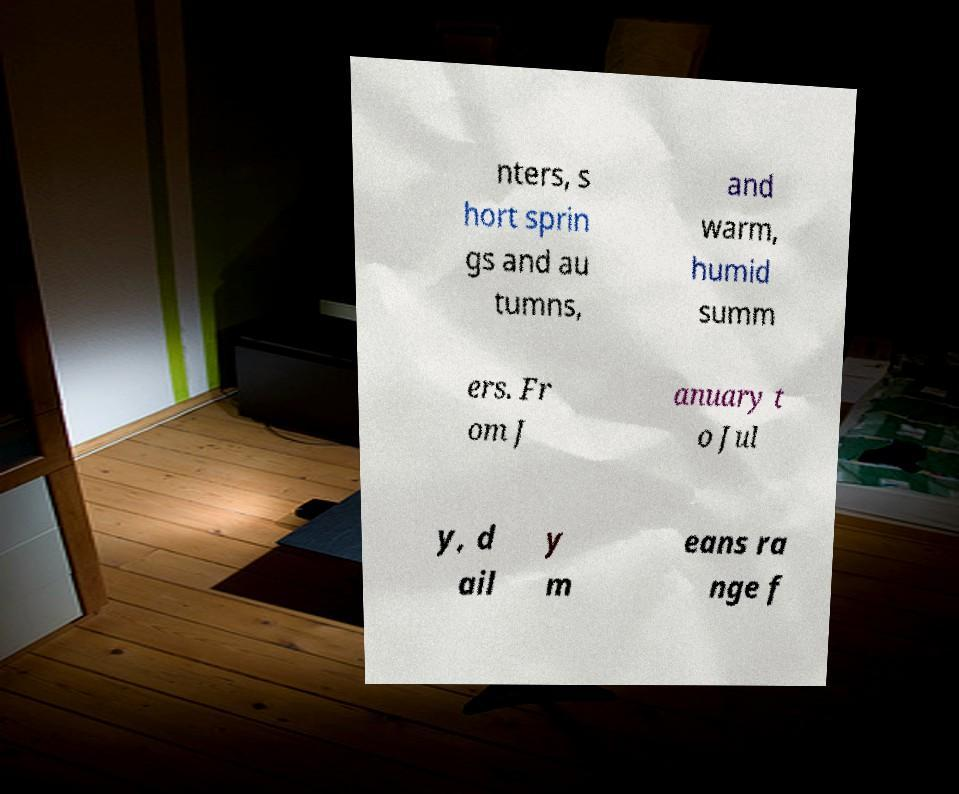What messages or text are displayed in this image? I need them in a readable, typed format. nters, s hort sprin gs and au tumns, and warm, humid summ ers. Fr om J anuary t o Jul y, d ail y m eans ra nge f 